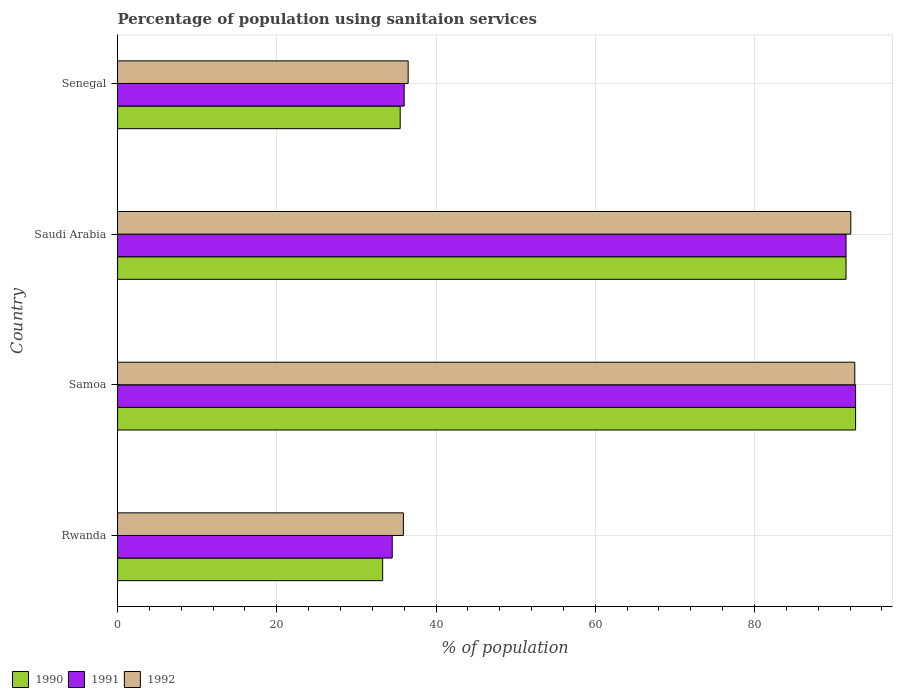How many different coloured bars are there?
Your answer should be very brief. 3. How many groups of bars are there?
Offer a terse response. 4. Are the number of bars per tick equal to the number of legend labels?
Your answer should be compact. Yes. Are the number of bars on each tick of the Y-axis equal?
Ensure brevity in your answer.  Yes. What is the label of the 2nd group of bars from the top?
Provide a succinct answer. Saudi Arabia. What is the percentage of population using sanitaion services in 1990 in Senegal?
Provide a succinct answer. 35.5. Across all countries, what is the maximum percentage of population using sanitaion services in 1992?
Give a very brief answer. 92.6. Across all countries, what is the minimum percentage of population using sanitaion services in 1990?
Your answer should be compact. 33.3. In which country was the percentage of population using sanitaion services in 1990 maximum?
Keep it short and to the point. Samoa. In which country was the percentage of population using sanitaion services in 1990 minimum?
Your answer should be compact. Rwanda. What is the total percentage of population using sanitaion services in 1991 in the graph?
Your answer should be compact. 254.7. What is the difference between the percentage of population using sanitaion services in 1992 in Rwanda and that in Saudi Arabia?
Your response must be concise. -56.2. What is the difference between the percentage of population using sanitaion services in 1991 in Saudi Arabia and the percentage of population using sanitaion services in 1992 in Rwanda?
Your answer should be compact. 55.6. What is the average percentage of population using sanitaion services in 1992 per country?
Your answer should be very brief. 64.28. What is the difference between the percentage of population using sanitaion services in 1992 and percentage of population using sanitaion services in 1991 in Samoa?
Give a very brief answer. -0.1. What is the ratio of the percentage of population using sanitaion services in 1991 in Samoa to that in Saudi Arabia?
Make the answer very short. 1.01. Is the percentage of population using sanitaion services in 1991 in Saudi Arabia less than that in Senegal?
Your answer should be compact. No. Is the difference between the percentage of population using sanitaion services in 1992 in Samoa and Saudi Arabia greater than the difference between the percentage of population using sanitaion services in 1991 in Samoa and Saudi Arabia?
Your response must be concise. No. What is the difference between the highest and the second highest percentage of population using sanitaion services in 1990?
Provide a succinct answer. 1.2. What is the difference between the highest and the lowest percentage of population using sanitaion services in 1991?
Provide a short and direct response. 58.2. In how many countries, is the percentage of population using sanitaion services in 1990 greater than the average percentage of population using sanitaion services in 1990 taken over all countries?
Ensure brevity in your answer.  2. What does the 1st bar from the top in Samoa represents?
Provide a succinct answer. 1992. Are all the bars in the graph horizontal?
Your response must be concise. Yes. Does the graph contain any zero values?
Give a very brief answer. No. Does the graph contain grids?
Your response must be concise. Yes. Where does the legend appear in the graph?
Offer a very short reply. Bottom left. What is the title of the graph?
Your response must be concise. Percentage of population using sanitaion services. What is the label or title of the X-axis?
Provide a short and direct response. % of population. What is the % of population in 1990 in Rwanda?
Your response must be concise. 33.3. What is the % of population in 1991 in Rwanda?
Your response must be concise. 34.5. What is the % of population of 1992 in Rwanda?
Offer a terse response. 35.9. What is the % of population of 1990 in Samoa?
Make the answer very short. 92.7. What is the % of population of 1991 in Samoa?
Provide a succinct answer. 92.7. What is the % of population of 1992 in Samoa?
Make the answer very short. 92.6. What is the % of population of 1990 in Saudi Arabia?
Provide a succinct answer. 91.5. What is the % of population of 1991 in Saudi Arabia?
Your answer should be compact. 91.5. What is the % of population in 1992 in Saudi Arabia?
Offer a terse response. 92.1. What is the % of population in 1990 in Senegal?
Provide a short and direct response. 35.5. What is the % of population in 1992 in Senegal?
Provide a short and direct response. 36.5. Across all countries, what is the maximum % of population of 1990?
Ensure brevity in your answer.  92.7. Across all countries, what is the maximum % of population in 1991?
Give a very brief answer. 92.7. Across all countries, what is the maximum % of population of 1992?
Your answer should be very brief. 92.6. Across all countries, what is the minimum % of population of 1990?
Your response must be concise. 33.3. Across all countries, what is the minimum % of population in 1991?
Provide a succinct answer. 34.5. Across all countries, what is the minimum % of population in 1992?
Provide a short and direct response. 35.9. What is the total % of population in 1990 in the graph?
Make the answer very short. 253. What is the total % of population in 1991 in the graph?
Provide a succinct answer. 254.7. What is the total % of population of 1992 in the graph?
Offer a very short reply. 257.1. What is the difference between the % of population of 1990 in Rwanda and that in Samoa?
Your answer should be very brief. -59.4. What is the difference between the % of population in 1991 in Rwanda and that in Samoa?
Ensure brevity in your answer.  -58.2. What is the difference between the % of population of 1992 in Rwanda and that in Samoa?
Keep it short and to the point. -56.7. What is the difference between the % of population in 1990 in Rwanda and that in Saudi Arabia?
Keep it short and to the point. -58.2. What is the difference between the % of population in 1991 in Rwanda and that in Saudi Arabia?
Provide a short and direct response. -57. What is the difference between the % of population in 1992 in Rwanda and that in Saudi Arabia?
Keep it short and to the point. -56.2. What is the difference between the % of population of 1990 in Rwanda and that in Senegal?
Ensure brevity in your answer.  -2.2. What is the difference between the % of population of 1991 in Rwanda and that in Senegal?
Make the answer very short. -1.5. What is the difference between the % of population of 1992 in Rwanda and that in Senegal?
Give a very brief answer. -0.6. What is the difference between the % of population of 1990 in Samoa and that in Saudi Arabia?
Your answer should be very brief. 1.2. What is the difference between the % of population of 1992 in Samoa and that in Saudi Arabia?
Provide a succinct answer. 0.5. What is the difference between the % of population of 1990 in Samoa and that in Senegal?
Keep it short and to the point. 57.2. What is the difference between the % of population of 1991 in Samoa and that in Senegal?
Your answer should be compact. 56.7. What is the difference between the % of population in 1992 in Samoa and that in Senegal?
Ensure brevity in your answer.  56.1. What is the difference between the % of population in 1991 in Saudi Arabia and that in Senegal?
Give a very brief answer. 55.5. What is the difference between the % of population in 1992 in Saudi Arabia and that in Senegal?
Provide a short and direct response. 55.6. What is the difference between the % of population of 1990 in Rwanda and the % of population of 1991 in Samoa?
Keep it short and to the point. -59.4. What is the difference between the % of population of 1990 in Rwanda and the % of population of 1992 in Samoa?
Your answer should be compact. -59.3. What is the difference between the % of population of 1991 in Rwanda and the % of population of 1992 in Samoa?
Offer a terse response. -58.1. What is the difference between the % of population in 1990 in Rwanda and the % of population in 1991 in Saudi Arabia?
Your answer should be compact. -58.2. What is the difference between the % of population in 1990 in Rwanda and the % of population in 1992 in Saudi Arabia?
Give a very brief answer. -58.8. What is the difference between the % of population in 1991 in Rwanda and the % of population in 1992 in Saudi Arabia?
Your response must be concise. -57.6. What is the difference between the % of population of 1990 in Rwanda and the % of population of 1991 in Senegal?
Offer a very short reply. -2.7. What is the difference between the % of population of 1990 in Rwanda and the % of population of 1992 in Senegal?
Provide a succinct answer. -3.2. What is the difference between the % of population in 1990 in Samoa and the % of population in 1991 in Saudi Arabia?
Give a very brief answer. 1.2. What is the difference between the % of population of 1990 in Samoa and the % of population of 1991 in Senegal?
Give a very brief answer. 56.7. What is the difference between the % of population of 1990 in Samoa and the % of population of 1992 in Senegal?
Your answer should be compact. 56.2. What is the difference between the % of population of 1991 in Samoa and the % of population of 1992 in Senegal?
Keep it short and to the point. 56.2. What is the difference between the % of population of 1990 in Saudi Arabia and the % of population of 1991 in Senegal?
Ensure brevity in your answer.  55.5. What is the average % of population of 1990 per country?
Make the answer very short. 63.25. What is the average % of population in 1991 per country?
Offer a very short reply. 63.67. What is the average % of population in 1992 per country?
Your response must be concise. 64.28. What is the difference between the % of population in 1990 and % of population in 1992 in Rwanda?
Ensure brevity in your answer.  -2.6. What is the difference between the % of population in 1990 and % of population in 1992 in Saudi Arabia?
Your answer should be compact. -0.6. What is the difference between the % of population of 1991 and % of population of 1992 in Saudi Arabia?
Provide a succinct answer. -0.6. What is the difference between the % of population of 1991 and % of population of 1992 in Senegal?
Make the answer very short. -0.5. What is the ratio of the % of population of 1990 in Rwanda to that in Samoa?
Your response must be concise. 0.36. What is the ratio of the % of population in 1991 in Rwanda to that in Samoa?
Your answer should be very brief. 0.37. What is the ratio of the % of population in 1992 in Rwanda to that in Samoa?
Your answer should be very brief. 0.39. What is the ratio of the % of population in 1990 in Rwanda to that in Saudi Arabia?
Give a very brief answer. 0.36. What is the ratio of the % of population in 1991 in Rwanda to that in Saudi Arabia?
Ensure brevity in your answer.  0.38. What is the ratio of the % of population in 1992 in Rwanda to that in Saudi Arabia?
Provide a short and direct response. 0.39. What is the ratio of the % of population in 1990 in Rwanda to that in Senegal?
Your answer should be very brief. 0.94. What is the ratio of the % of population in 1991 in Rwanda to that in Senegal?
Make the answer very short. 0.96. What is the ratio of the % of population of 1992 in Rwanda to that in Senegal?
Your answer should be compact. 0.98. What is the ratio of the % of population in 1990 in Samoa to that in Saudi Arabia?
Make the answer very short. 1.01. What is the ratio of the % of population in 1991 in Samoa to that in Saudi Arabia?
Your answer should be compact. 1.01. What is the ratio of the % of population in 1992 in Samoa to that in Saudi Arabia?
Offer a terse response. 1.01. What is the ratio of the % of population in 1990 in Samoa to that in Senegal?
Provide a succinct answer. 2.61. What is the ratio of the % of population of 1991 in Samoa to that in Senegal?
Your answer should be compact. 2.58. What is the ratio of the % of population of 1992 in Samoa to that in Senegal?
Your response must be concise. 2.54. What is the ratio of the % of population of 1990 in Saudi Arabia to that in Senegal?
Make the answer very short. 2.58. What is the ratio of the % of population in 1991 in Saudi Arabia to that in Senegal?
Offer a very short reply. 2.54. What is the ratio of the % of population of 1992 in Saudi Arabia to that in Senegal?
Offer a terse response. 2.52. What is the difference between the highest and the second highest % of population in 1990?
Provide a short and direct response. 1.2. What is the difference between the highest and the second highest % of population in 1991?
Offer a terse response. 1.2. What is the difference between the highest and the second highest % of population of 1992?
Your answer should be compact. 0.5. What is the difference between the highest and the lowest % of population of 1990?
Your answer should be very brief. 59.4. What is the difference between the highest and the lowest % of population of 1991?
Keep it short and to the point. 58.2. What is the difference between the highest and the lowest % of population in 1992?
Offer a terse response. 56.7. 